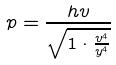Convert formula to latex. <formula><loc_0><loc_0><loc_500><loc_500>p = \frac { h v } { \sqrt { 1 \cdot \frac { v ^ { 4 } } { y ^ { 4 } } } }</formula> 